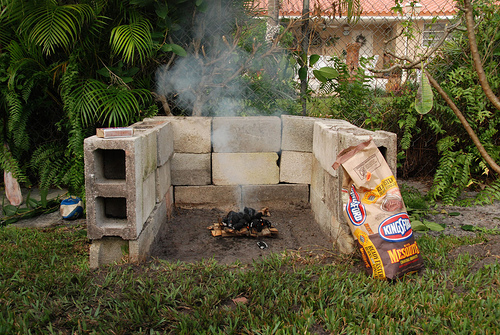<image>
Is there a fire on the charcoal? No. The fire is not positioned on the charcoal. They may be near each other, but the fire is not supported by or resting on top of the charcoal. Where is the smoke in relation to the cement block? Is it above the cement block? Yes. The smoke is positioned above the cement block in the vertical space, higher up in the scene. 